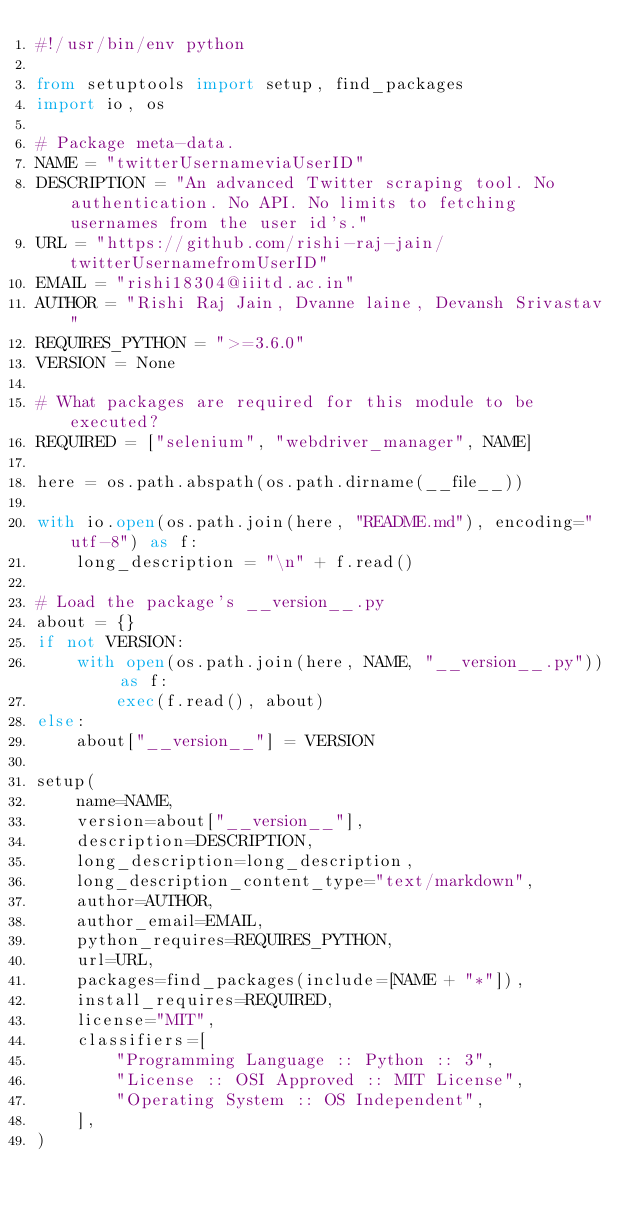<code> <loc_0><loc_0><loc_500><loc_500><_Python_>#!/usr/bin/env python

from setuptools import setup, find_packages
import io, os

# Package meta-data.
NAME = "twitterUsernameviaUserID"
DESCRIPTION = "An advanced Twitter scraping tool. No authentication. No API. No limits to fetching usernames from the user id's."
URL = "https://github.com/rishi-raj-jain/twitterUsernamefromUserID"
EMAIL = "rishi18304@iiitd.ac.in"
AUTHOR = "Rishi Raj Jain, Dvanne laine, Devansh Srivastav"
REQUIRES_PYTHON = ">=3.6.0"
VERSION = None

# What packages are required for this module to be executed?
REQUIRED = ["selenium", "webdriver_manager", NAME]

here = os.path.abspath(os.path.dirname(__file__))

with io.open(os.path.join(here, "README.md"), encoding="utf-8") as f:
    long_description = "\n" + f.read()

# Load the package's __version__.py
about = {}
if not VERSION:
    with open(os.path.join(here, NAME, "__version__.py")) as f:
        exec(f.read(), about)
else:
    about["__version__"] = VERSION

setup(
    name=NAME,
    version=about["__version__"],
    description=DESCRIPTION,
    long_description=long_description,
    long_description_content_type="text/markdown",
    author=AUTHOR,
    author_email=EMAIL,
    python_requires=REQUIRES_PYTHON,
    url=URL,
    packages=find_packages(include=[NAME + "*"]),
    install_requires=REQUIRED,
    license="MIT",
    classifiers=[
        "Programming Language :: Python :: 3",
        "License :: OSI Approved :: MIT License",
        "Operating System :: OS Independent",
    ],
)</code> 